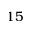Convert formula to latex. <formula><loc_0><loc_0><loc_500><loc_500>1 5</formula> 